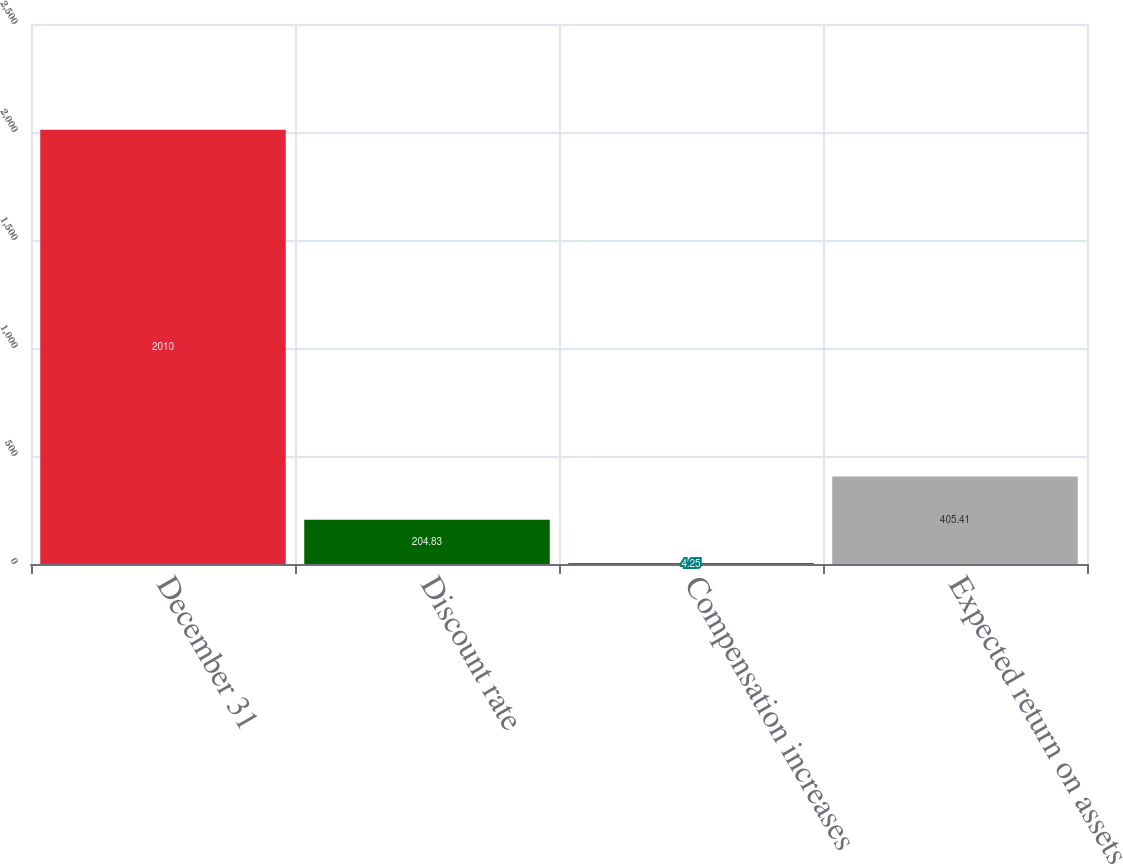Convert chart to OTSL. <chart><loc_0><loc_0><loc_500><loc_500><bar_chart><fcel>December 31<fcel>Discount rate<fcel>Compensation increases<fcel>Expected return on assets<nl><fcel>2010<fcel>204.83<fcel>4.25<fcel>405.41<nl></chart> 